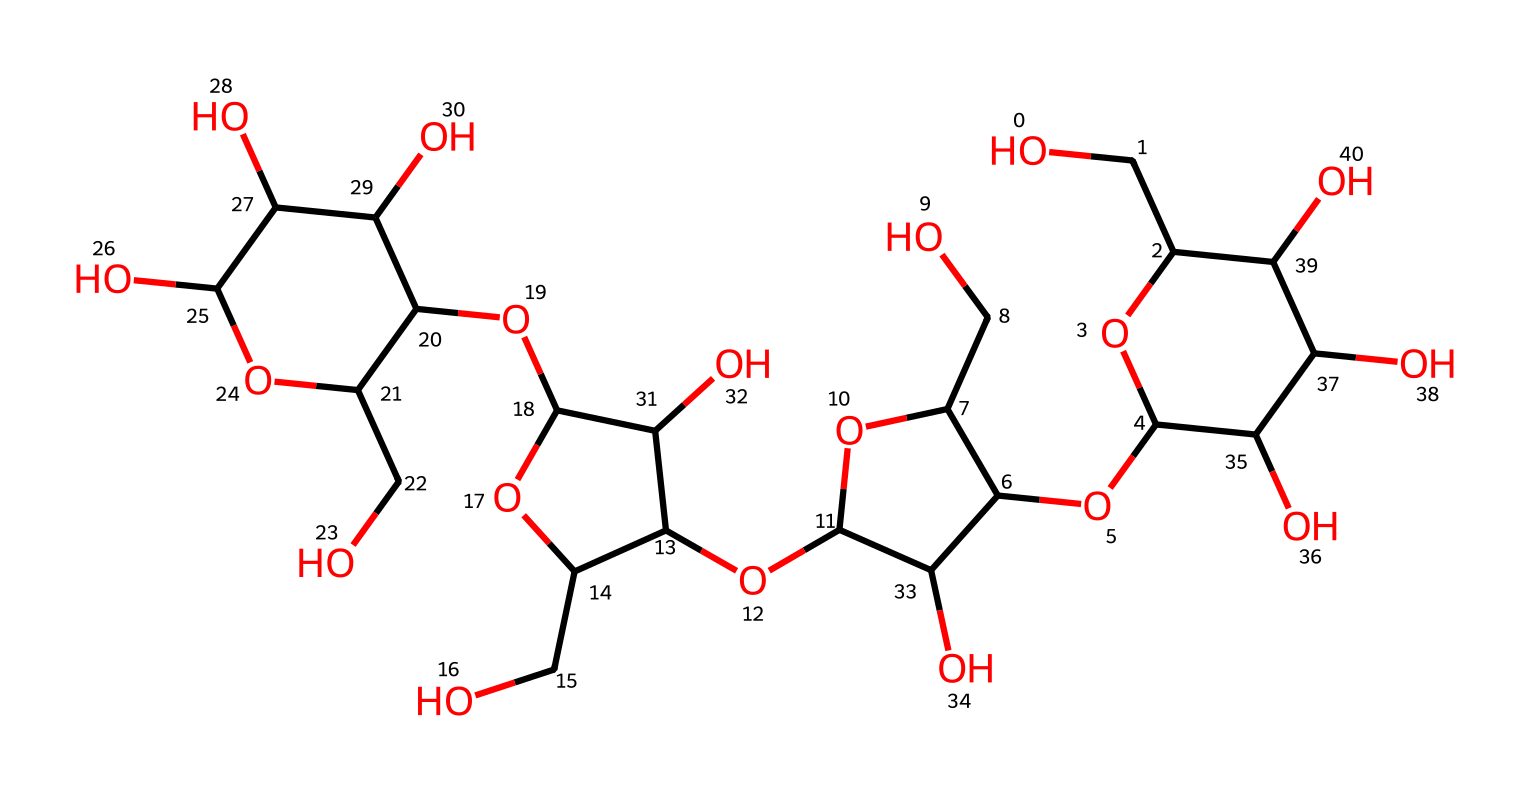What is the molecular formula for the cellulose in this structure? By analyzing the structure and counting the carbon (C), hydrogen (H), and oxygen (O) atoms, we find that there are 6 carbon atoms, 10 hydrogen atoms, and 5 oxygen atoms in each repeating unit, leading to a generic molecular formula of C6H10O5 for cellulose.
Answer: C6H10O5 How many hydroxyl (-OH) groups does this cellulose contain? In the chemical structure, each -OH (hydroxyl) group is present on the carbon atoms, and by counting these groups in the structure, we find there are 6 -OH groups attached to the carbon backbone of the cellulose.
Answer: 6 What kind of polymer is represented by this chemical structure? The structure shows that it consists of repeating glucose units connected by glycosidic bonds, indicating that it is a polysaccharide or specifically a cellulose polymer.
Answer: polysaccharide What is the primary function of cellulose in game packaging? Cellulose provides strength and durability to materials, making it ideal for packaging because it is biodegradable and eco-friendly, which is also attractive for sustainable game packaging solutions.
Answer: strength What type of bonding connects the glucose units in cellulose? The glucose units in cellulose are connected by beta-1,4-glycosidic bonds, which maintain the linear structure necessary for fiber formation.
Answer: beta-1,4-glycosidic bonds What role does cellulose play in environmental sustainability? Cellulose is derived from plants and is biodegradable, which contributes to reducing plastic waste and promoting eco-friendly packaging solutions, making it a sustainable choice in packaging materials.
Answer: biodegradable 